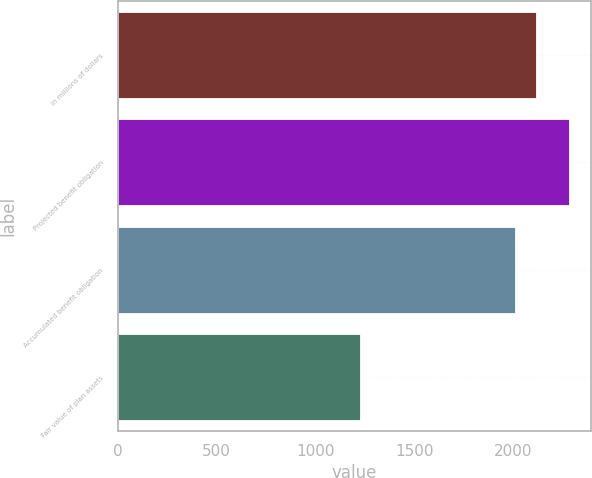Convert chart. <chart><loc_0><loc_0><loc_500><loc_500><bar_chart><fcel>In millions of dollars<fcel>Projected benefit obligation<fcel>Accumulated benefit obligation<fcel>Fair value of plan assets<nl><fcel>2117.8<fcel>2282<fcel>2012<fcel>1224<nl></chart> 